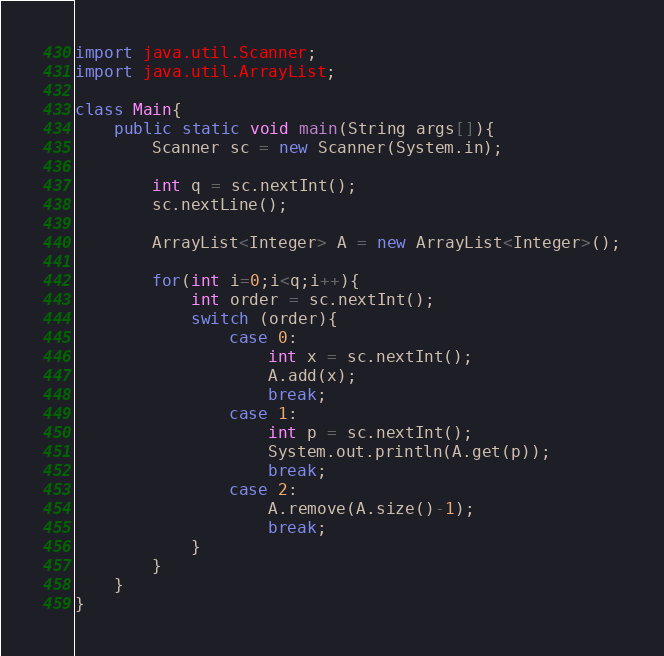<code> <loc_0><loc_0><loc_500><loc_500><_Java_>import java.util.Scanner;
import java.util.ArrayList;

class Main{
    public static void main(String args[]){
        Scanner sc = new Scanner(System.in);

        int q = sc.nextInt();
        sc.nextLine();

        ArrayList<Integer> A = new ArrayList<Integer>();

        for(int i=0;i<q;i++){
            int order = sc.nextInt();
            switch (order){
                case 0:
                    int x = sc.nextInt();
                    A.add(x);
                    break;
                case 1:
                    int p = sc.nextInt();
                    System.out.println(A.get(p));
                    break;
                case 2:
                    A.remove(A.size()-1);
                    break;
            }
        }
    }
}
</code> 